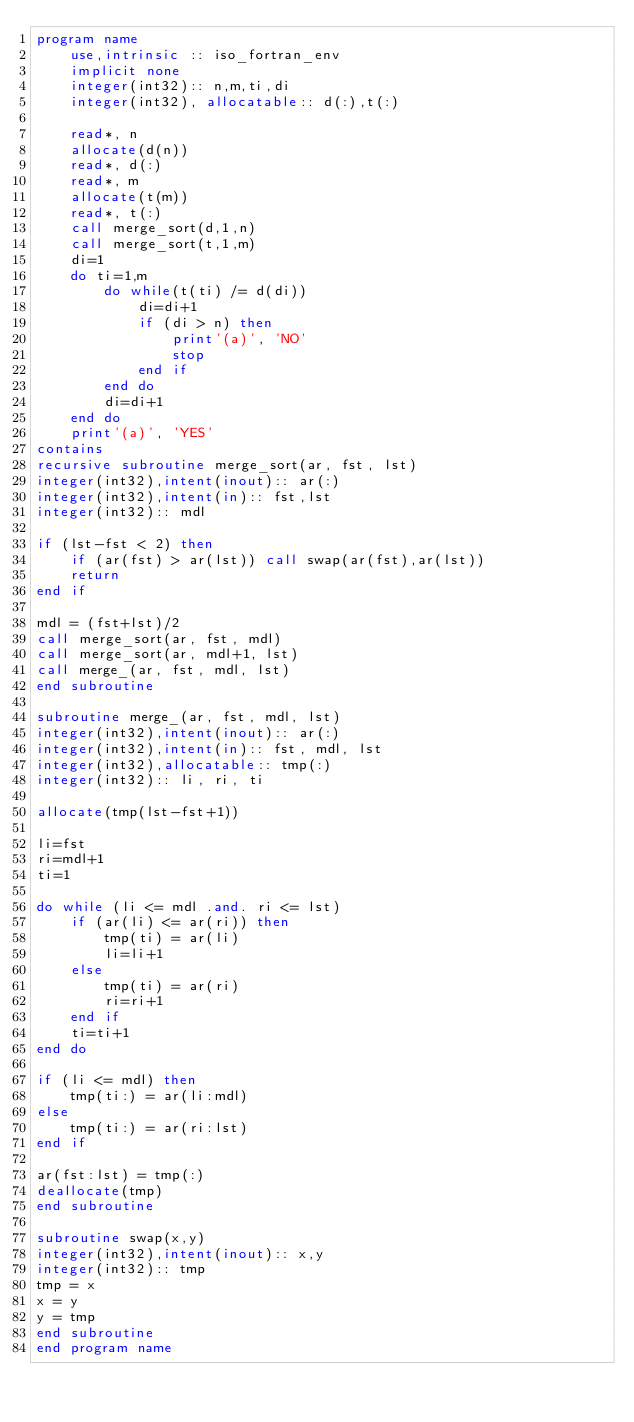<code> <loc_0><loc_0><loc_500><loc_500><_FORTRAN_>program name
    use,intrinsic :: iso_fortran_env
    implicit none
    integer(int32):: n,m,ti,di
    integer(int32), allocatable:: d(:),t(:)

    read*, n
    allocate(d(n))
    read*, d(:)
    read*, m
    allocate(t(m))
    read*, t(:)
    call merge_sort(d,1,n)
    call merge_sort(t,1,m)
    di=1
    do ti=1,m
        do while(t(ti) /= d(di))
            di=di+1
            if (di > n) then
                print'(a)', 'NO'
                stop
            end if
        end do
        di=di+1
    end do
    print'(a)', 'YES'
contains
recursive subroutine merge_sort(ar, fst, lst)
integer(int32),intent(inout):: ar(:)
integer(int32),intent(in):: fst,lst
integer(int32):: mdl

if (lst-fst < 2) then
    if (ar(fst) > ar(lst)) call swap(ar(fst),ar(lst))
    return
end if

mdl = (fst+lst)/2
call merge_sort(ar, fst, mdl)
call merge_sort(ar, mdl+1, lst)
call merge_(ar, fst, mdl, lst)
end subroutine

subroutine merge_(ar, fst, mdl, lst)
integer(int32),intent(inout):: ar(:)
integer(int32),intent(in):: fst, mdl, lst
integer(int32),allocatable:: tmp(:)
integer(int32):: li, ri, ti

allocate(tmp(lst-fst+1))

li=fst
ri=mdl+1   
ti=1

do while (li <= mdl .and. ri <= lst)
    if (ar(li) <= ar(ri)) then
        tmp(ti) = ar(li)
        li=li+1
    else
        tmp(ti) = ar(ri)
        ri=ri+1
    end if
    ti=ti+1
end do

if (li <= mdl) then
    tmp(ti:) = ar(li:mdl)
else
    tmp(ti:) = ar(ri:lst)
end if

ar(fst:lst) = tmp(:)
deallocate(tmp)
end subroutine

subroutine swap(x,y)
integer(int32),intent(inout):: x,y
integer(int32):: tmp
tmp = x
x = y
y = tmp
end subroutine
end program name</code> 